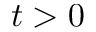Convert formula to latex. <formula><loc_0><loc_0><loc_500><loc_500>t > 0</formula> 